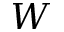<formula> <loc_0><loc_0><loc_500><loc_500>W</formula> 